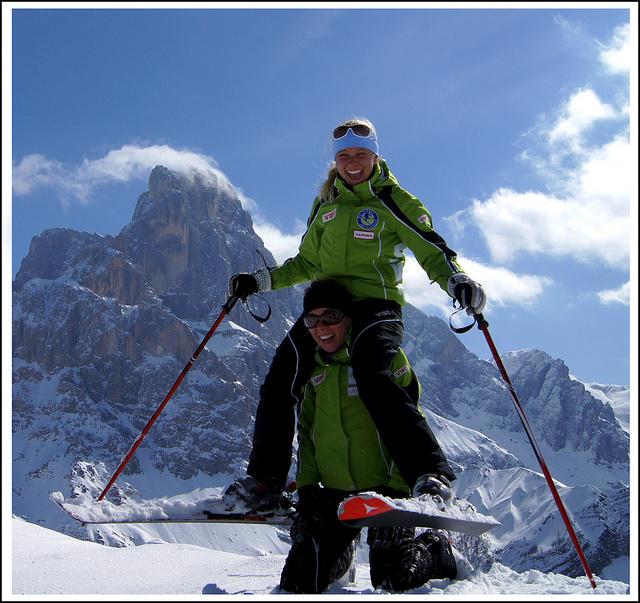Is this one person or two?
Quick response, please. 2. Are they sad?
Be succinct. No. What color are the jackets?
Keep it brief. Green. 